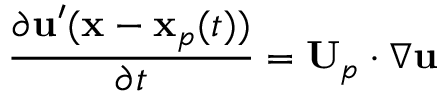<formula> <loc_0><loc_0><loc_500><loc_500>\frac { \partial u ^ { \prime } ( x - x _ { p } ( t ) ) } { \partial t } = U _ { p } \cdot \nabla u</formula> 